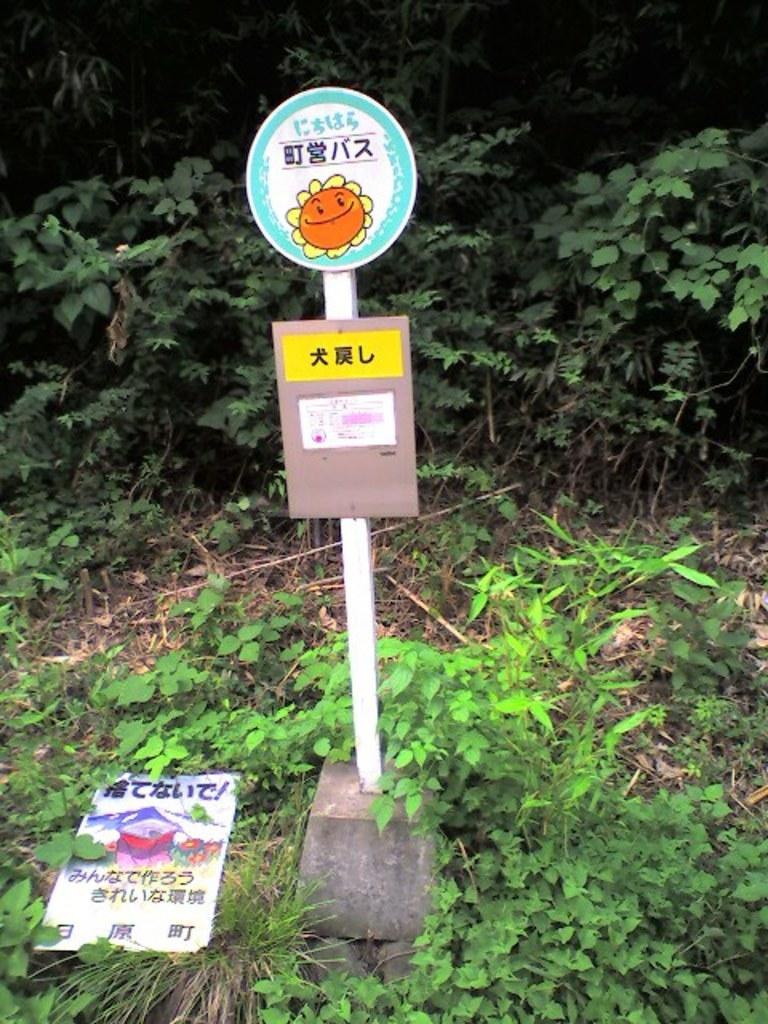What type of living organisms can be seen in the image? Plants can be seen in the image. What is the tall, vertical object in the image? There is a pole in the image. What are the flat, rectangular objects in the image? There are boards in the image. What type of ground surface is visible in the image? There is grass in the image. How many trees are visible on the hill in the image? There is no hill or trees present in the image. What type of bulb is used to light up the plants in the image? There is no mention of any bulbs or lighting in the image; it only features plants, a pole, and boards. 